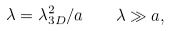<formula> <loc_0><loc_0><loc_500><loc_500>\lambda = \lambda _ { 3 D } ^ { 2 } / a \, \quad \lambda \gg a ,</formula> 